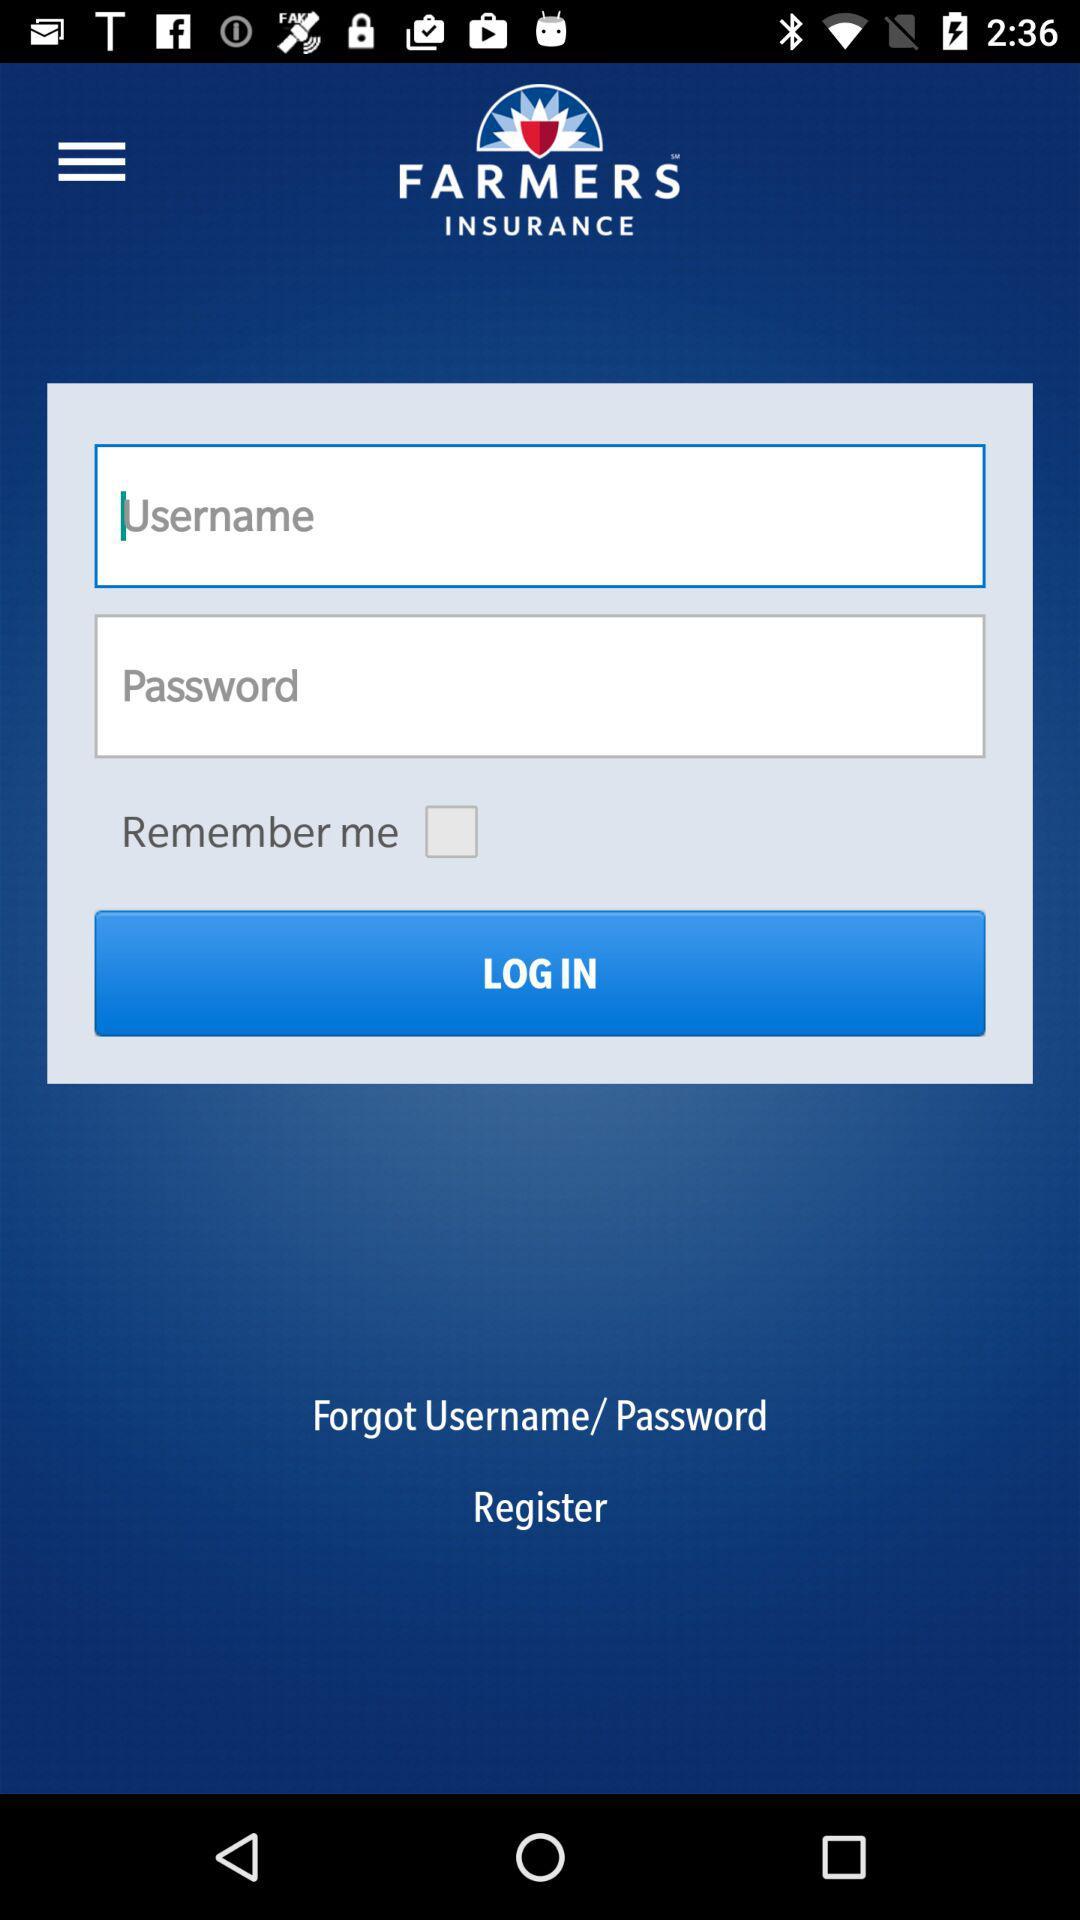What is the status of "Remember me"? The status is "off". 